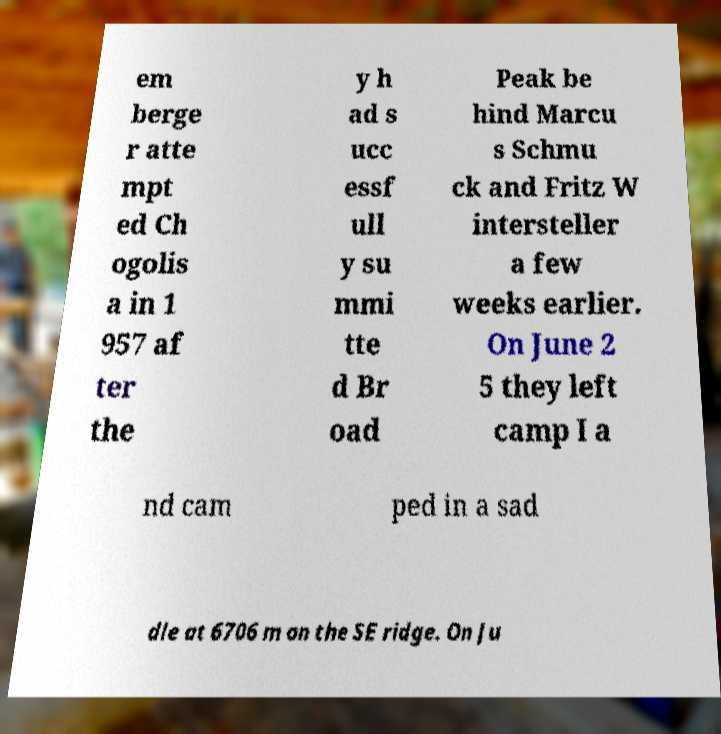Can you read and provide the text displayed in the image?This photo seems to have some interesting text. Can you extract and type it out for me? em berge r atte mpt ed Ch ogolis a in 1 957 af ter the y h ad s ucc essf ull y su mmi tte d Br oad Peak be hind Marcu s Schmu ck and Fritz W intersteller a few weeks earlier. On June 2 5 they left camp I a nd cam ped in a sad dle at 6706 m on the SE ridge. On Ju 